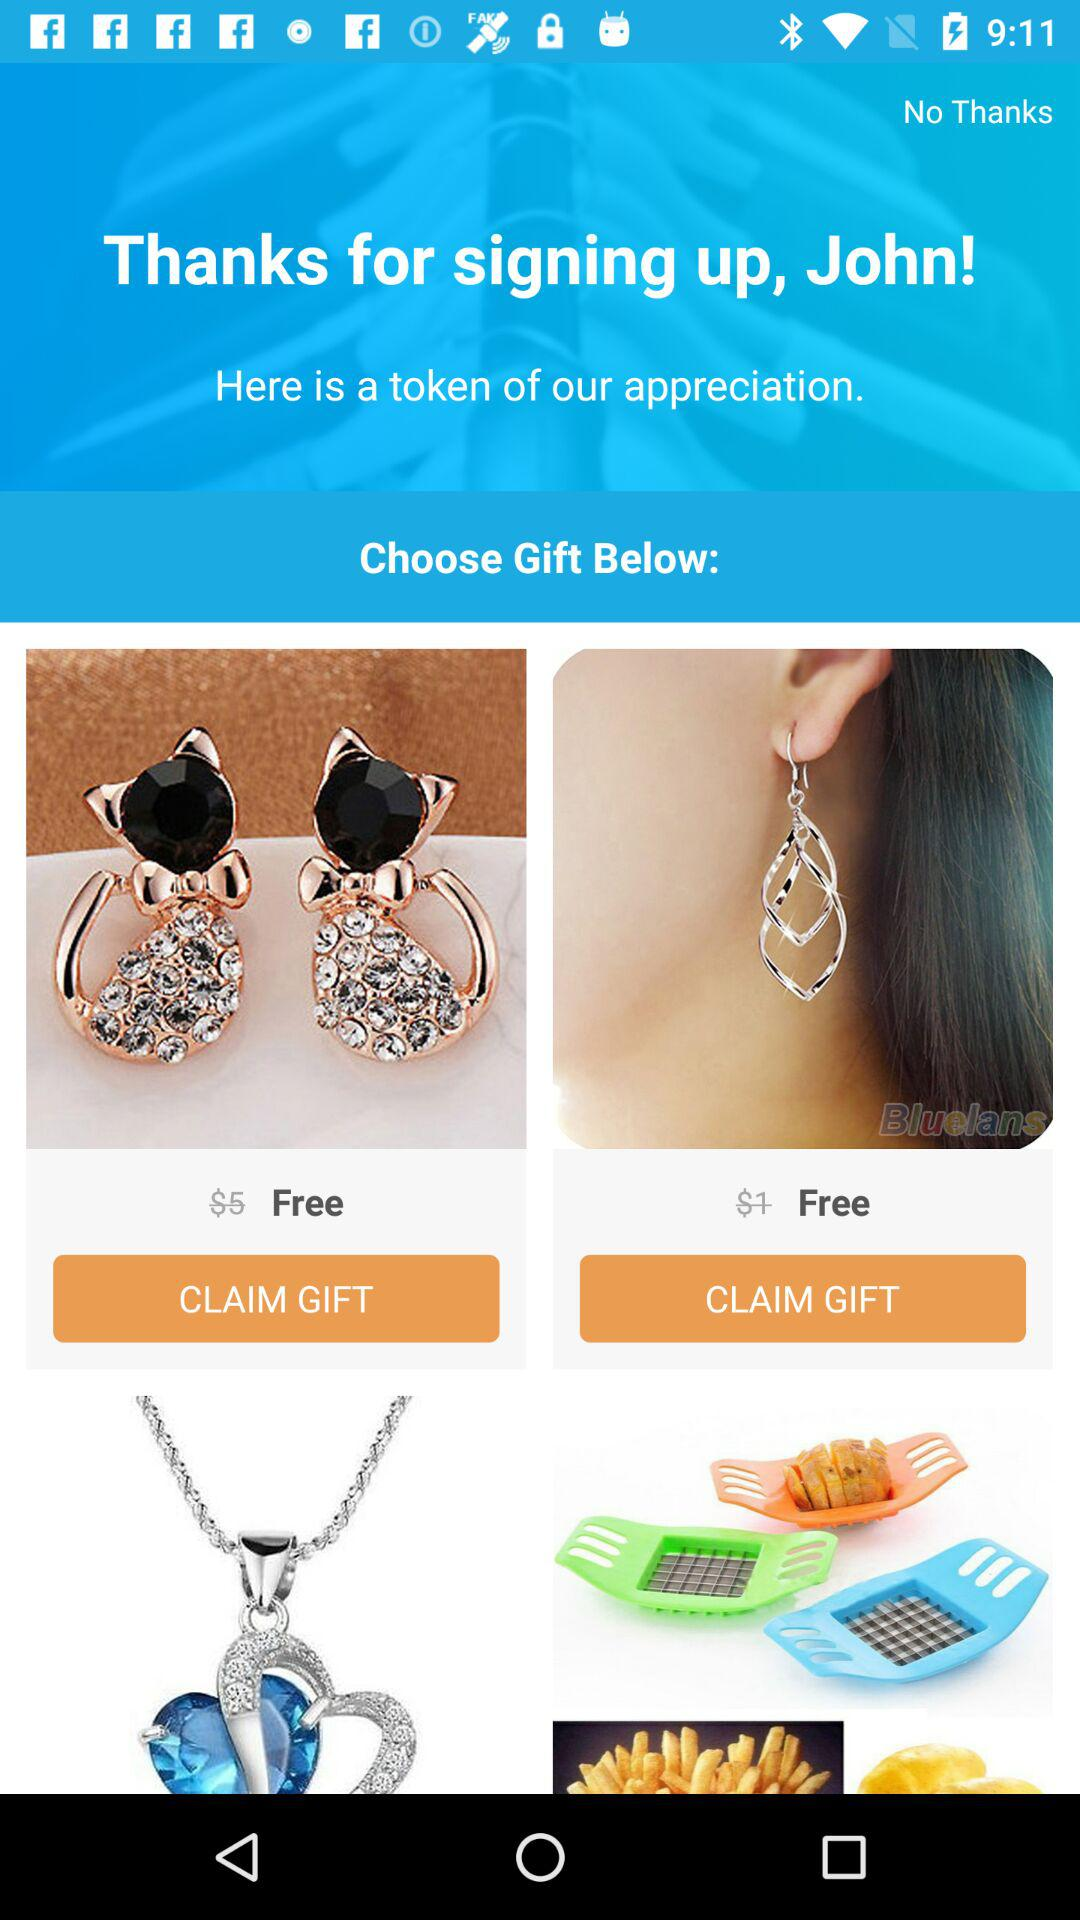How many gifts are free?
Answer the question using a single word or phrase. 2 